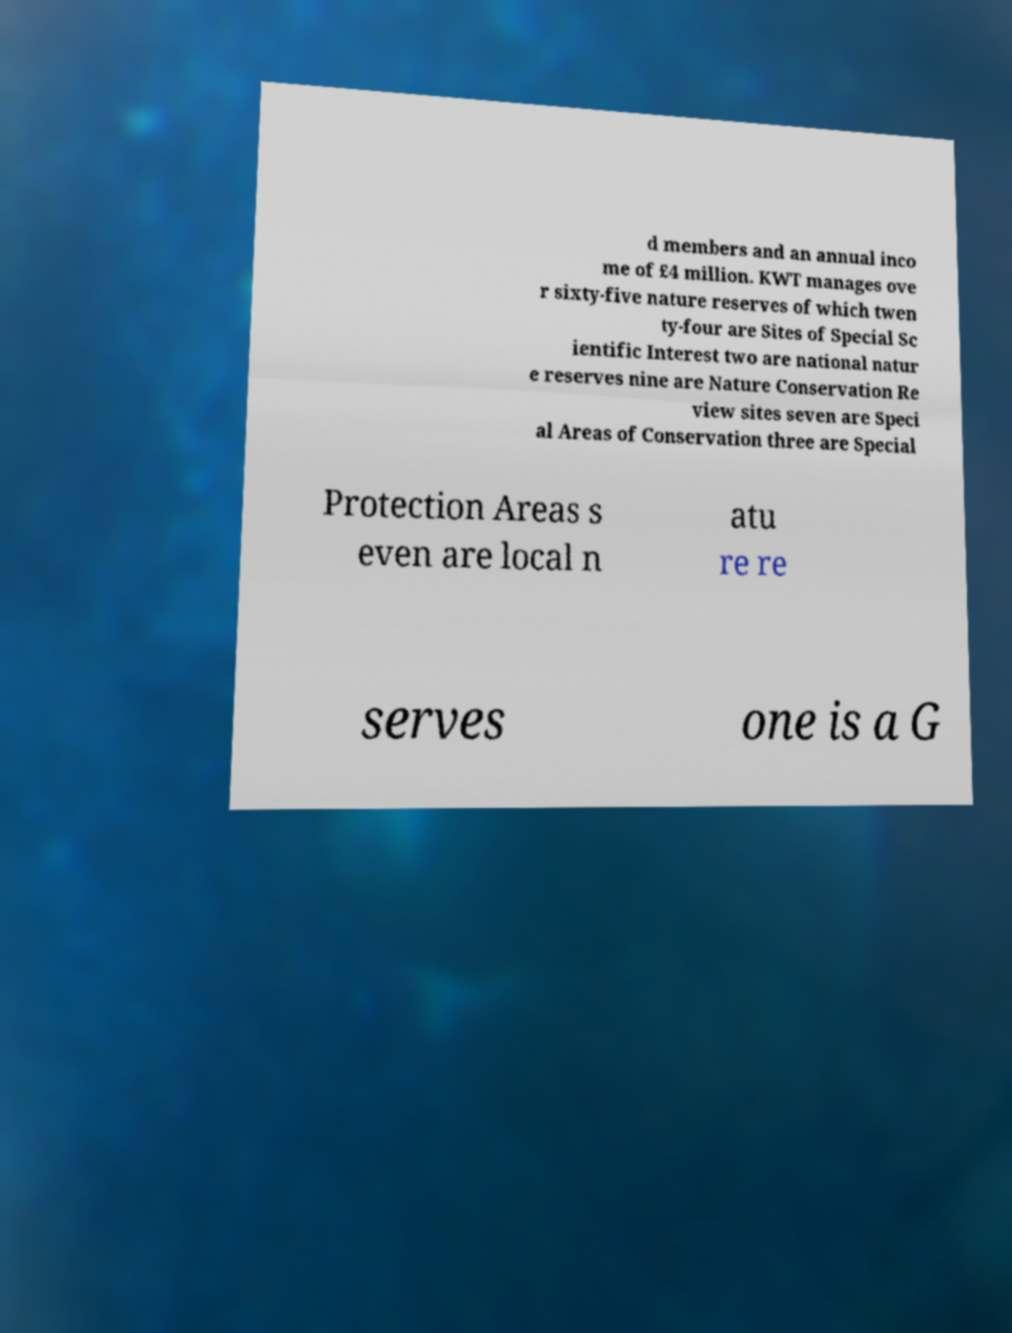There's text embedded in this image that I need extracted. Can you transcribe it verbatim? d members and an annual inco me of £4 million. KWT manages ove r sixty-five nature reserves of which twen ty-four are Sites of Special Sc ientific Interest two are national natur e reserves nine are Nature Conservation Re view sites seven are Speci al Areas of Conservation three are Special Protection Areas s even are local n atu re re serves one is a G 